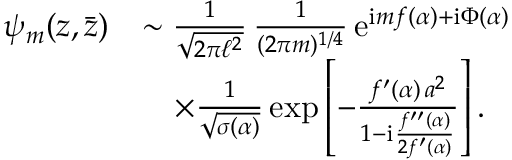Convert formula to latex. <formula><loc_0><loc_0><loc_500><loc_500>\begin{array} { r l } { \psi _ { m } ( z , \bar { z } ) } & { \sim \frac { 1 } { \sqrt { 2 \pi \ell ^ { 2 } } } \, \frac { 1 } { ( 2 \pi m ) ^ { 1 / 4 } } \, e ^ { i m f ( \alpha ) + i \Phi ( \alpha ) } } \\ & { \quad \times \frac { 1 } { \sqrt { \sigma ( \alpha ) } } \exp \left [ - \frac { f ^ { \prime } ( \alpha ) \, a ^ { 2 } } { 1 - i \frac { f ^ { \prime \prime } ( \alpha ) } { 2 f ^ { \prime } ( \alpha ) } } \right ] . } \end{array}</formula> 